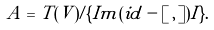Convert formula to latex. <formula><loc_0><loc_0><loc_500><loc_500>A = T ( V ) / \{ I m ( i d - [ \, , \, ] ) I \} .</formula> 